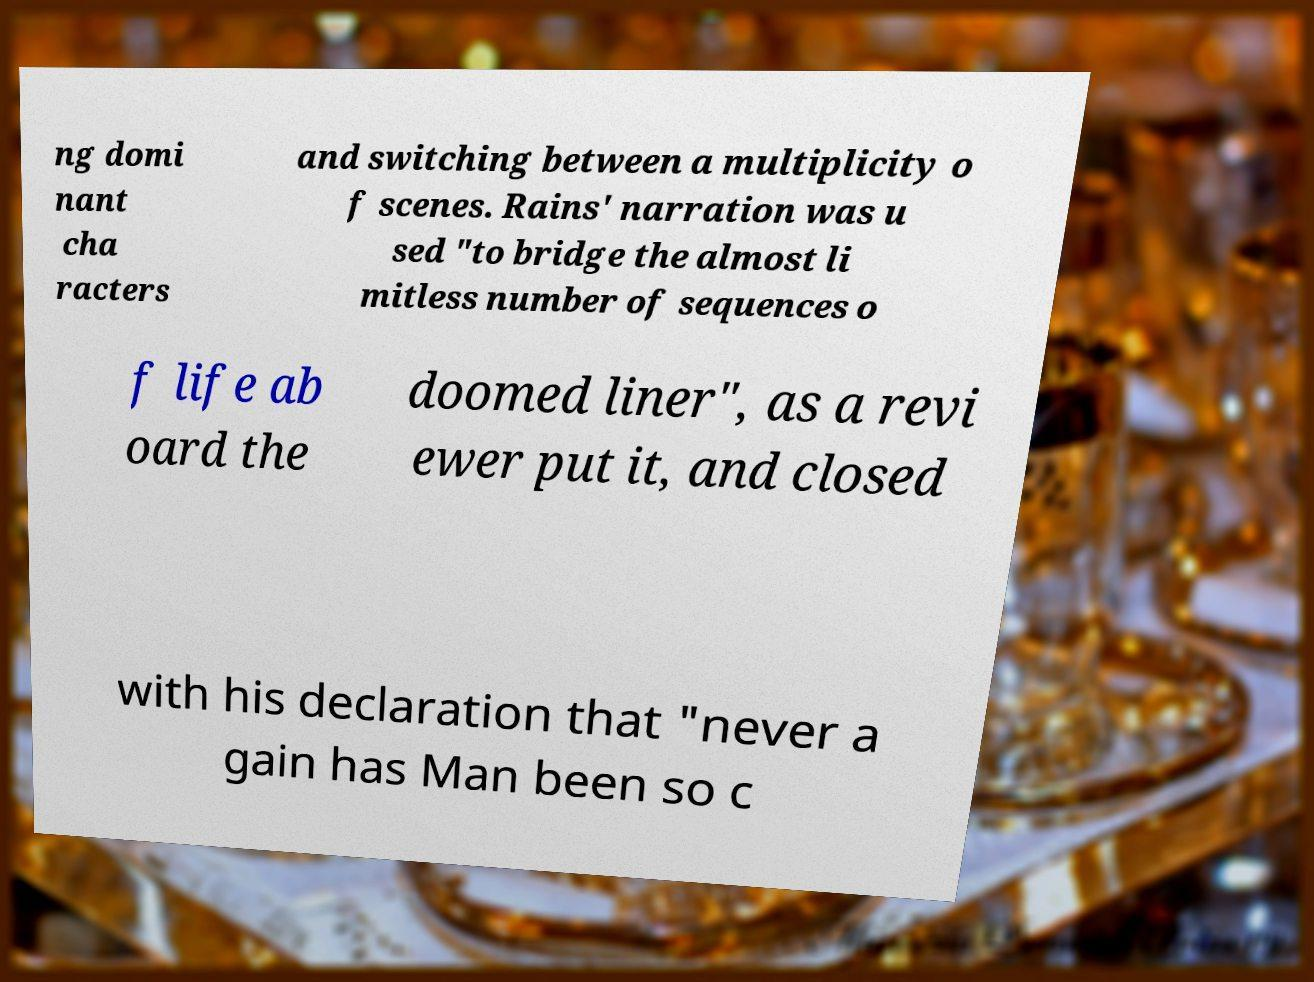Could you assist in decoding the text presented in this image and type it out clearly? ng domi nant cha racters and switching between a multiplicity o f scenes. Rains' narration was u sed "to bridge the almost li mitless number of sequences o f life ab oard the doomed liner", as a revi ewer put it, and closed with his declaration that "never a gain has Man been so c 